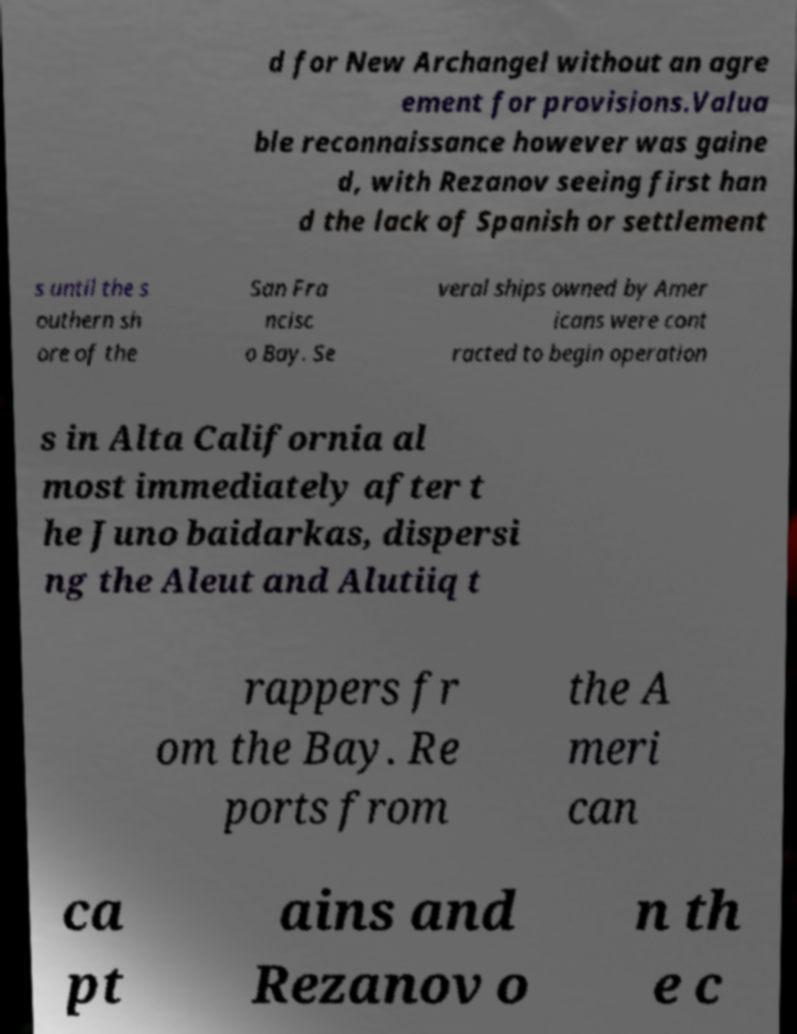Can you accurately transcribe the text from the provided image for me? d for New Archangel without an agre ement for provisions.Valua ble reconnaissance however was gaine d, with Rezanov seeing first han d the lack of Spanish or settlement s until the s outhern sh ore of the San Fra ncisc o Bay. Se veral ships owned by Amer icans were cont racted to begin operation s in Alta California al most immediately after t he Juno baidarkas, dispersi ng the Aleut and Alutiiq t rappers fr om the Bay. Re ports from the A meri can ca pt ains and Rezanov o n th e c 